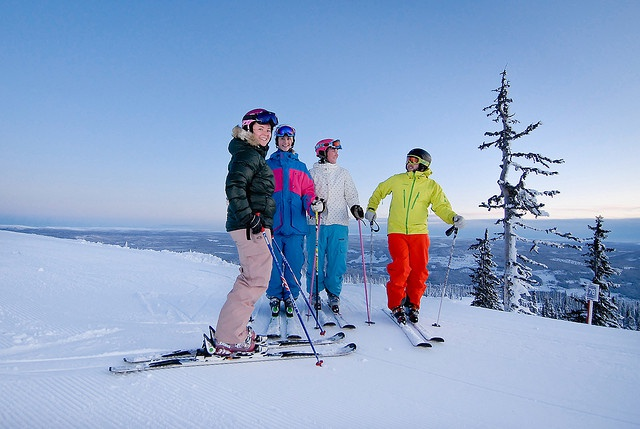Describe the objects in this image and their specific colors. I can see people in gray, darkgray, black, and navy tones, people in gray, brown, red, khaki, and olive tones, people in gray, blue, navy, darkblue, and black tones, people in gray, teal, darkgray, and lightgray tones, and skis in gray, darkgray, lightgray, and black tones in this image. 